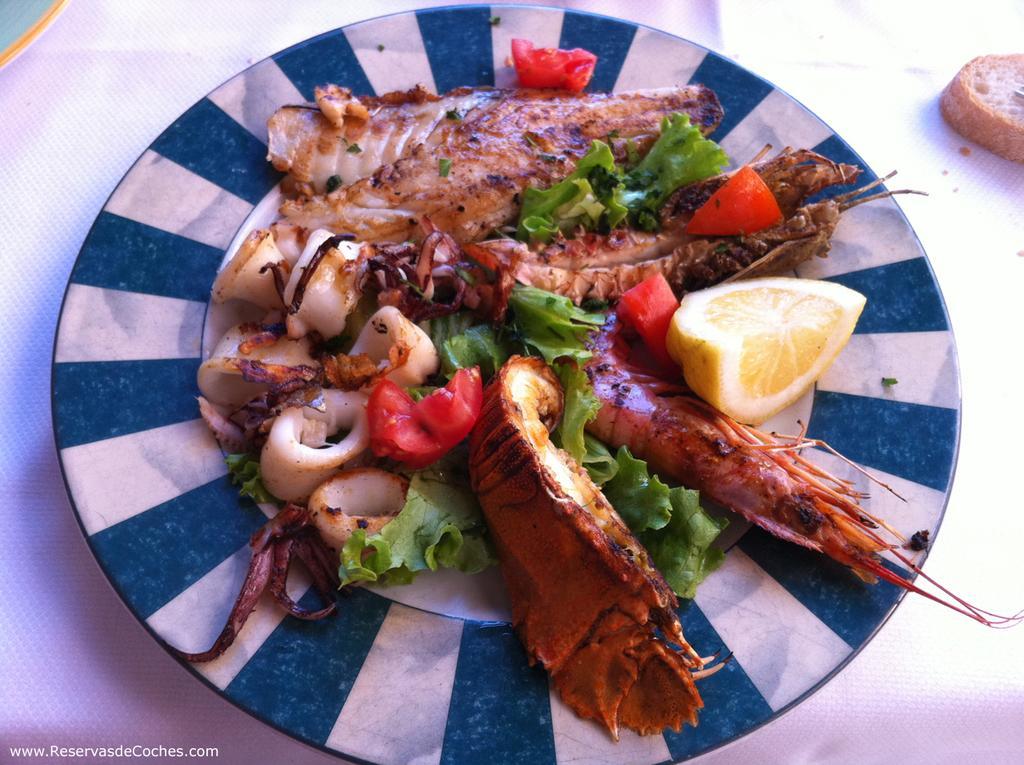In one or two sentences, can you explain what this image depicts? In the image there is salad with fry prawns and lemon slice on a plate over a table with a bread slice on the right side corner. 